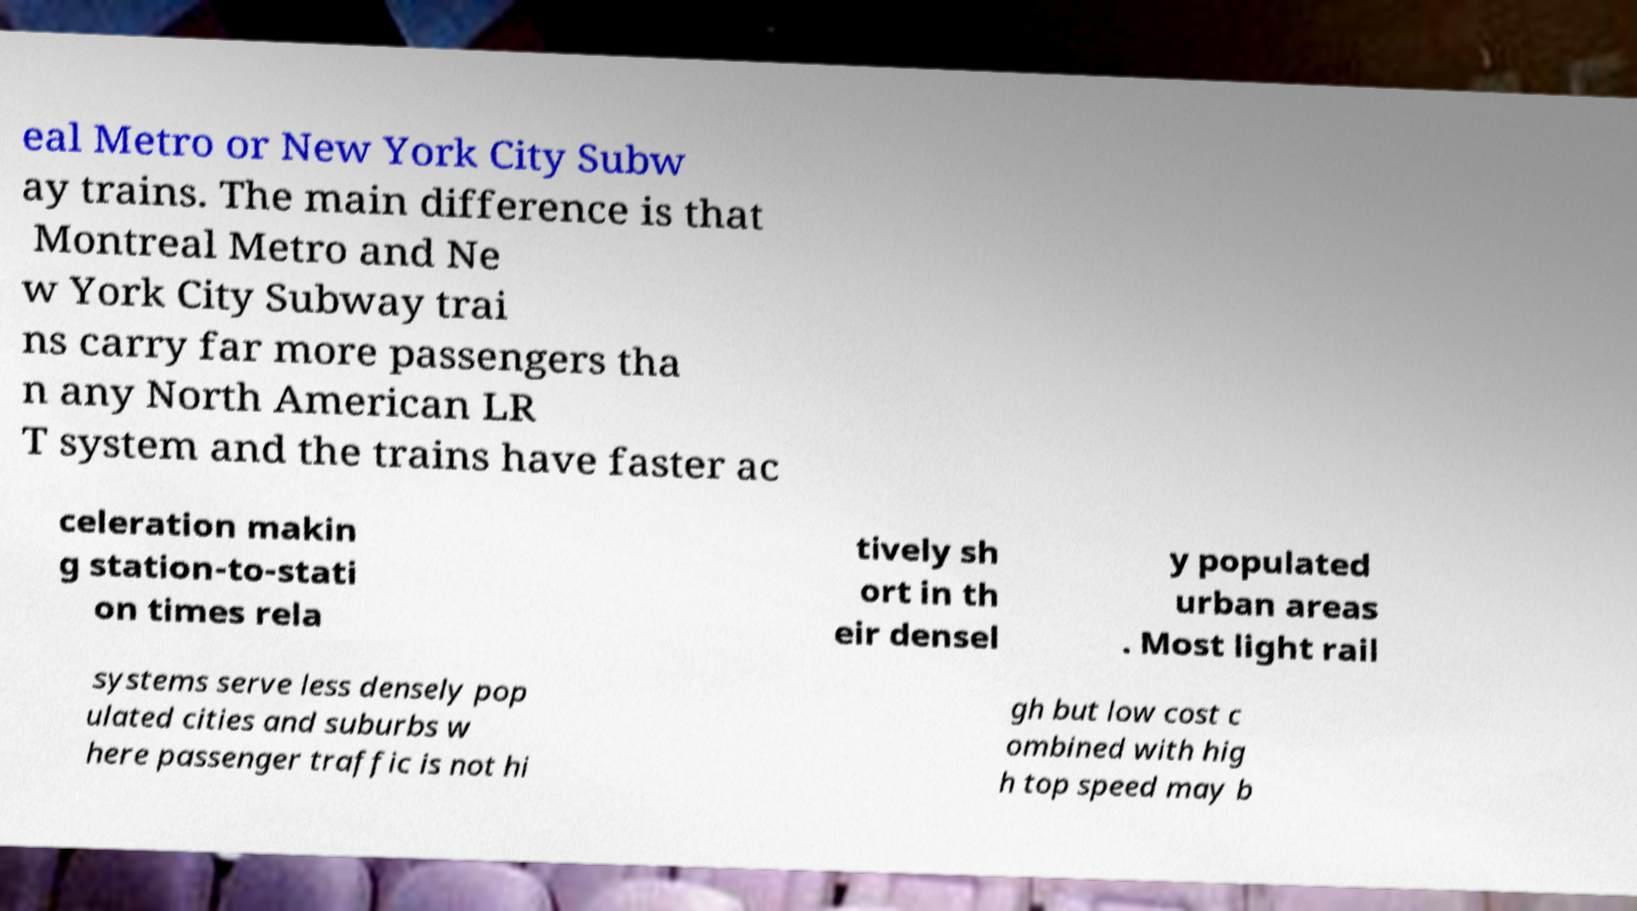Could you extract and type out the text from this image? eal Metro or New York City Subw ay trains. The main difference is that Montreal Metro and Ne w York City Subway trai ns carry far more passengers tha n any North American LR T system and the trains have faster ac celeration makin g station-to-stati on times rela tively sh ort in th eir densel y populated urban areas . Most light rail systems serve less densely pop ulated cities and suburbs w here passenger traffic is not hi gh but low cost c ombined with hig h top speed may b 